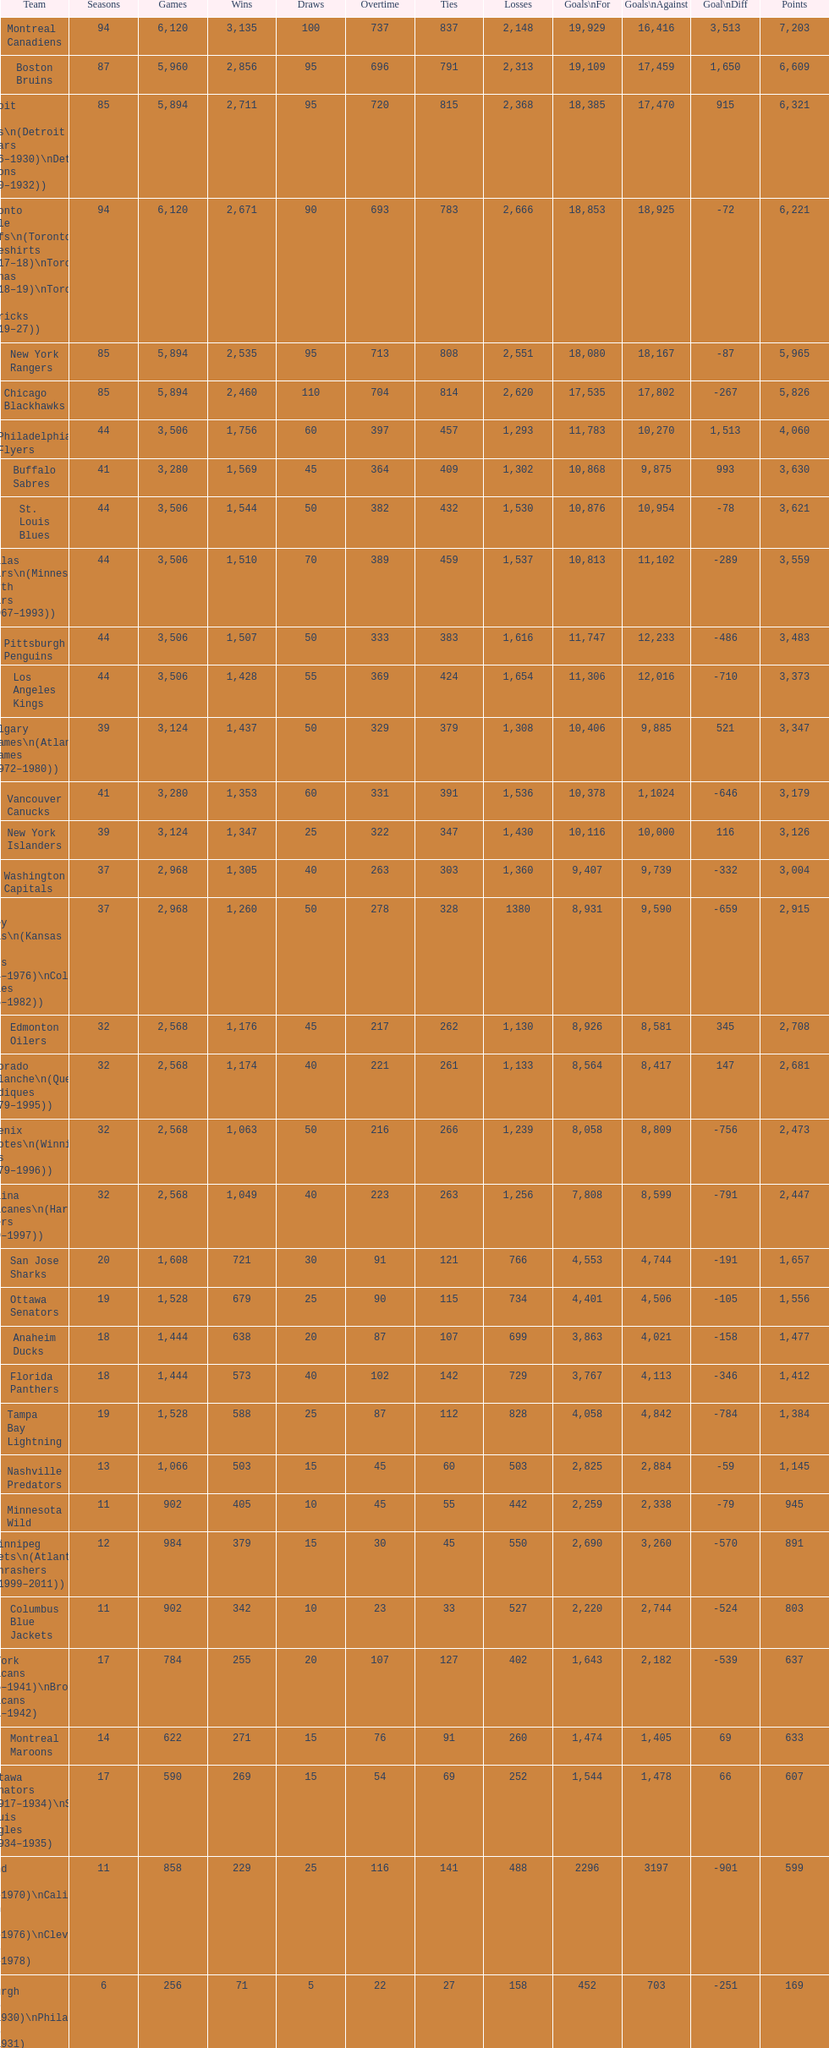How many teams have won more than 1,500 games? 11. 